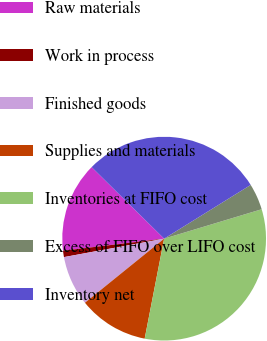<chart> <loc_0><loc_0><loc_500><loc_500><pie_chart><fcel>Raw materials<fcel>Work in process<fcel>Finished goods<fcel>Supplies and materials<fcel>Inventories at FIFO cost<fcel>Excess of FIFO over LIFO cost<fcel>Inventory net<nl><fcel>14.28%<fcel>1.01%<fcel>7.93%<fcel>11.11%<fcel>32.72%<fcel>4.18%<fcel>28.76%<nl></chart> 